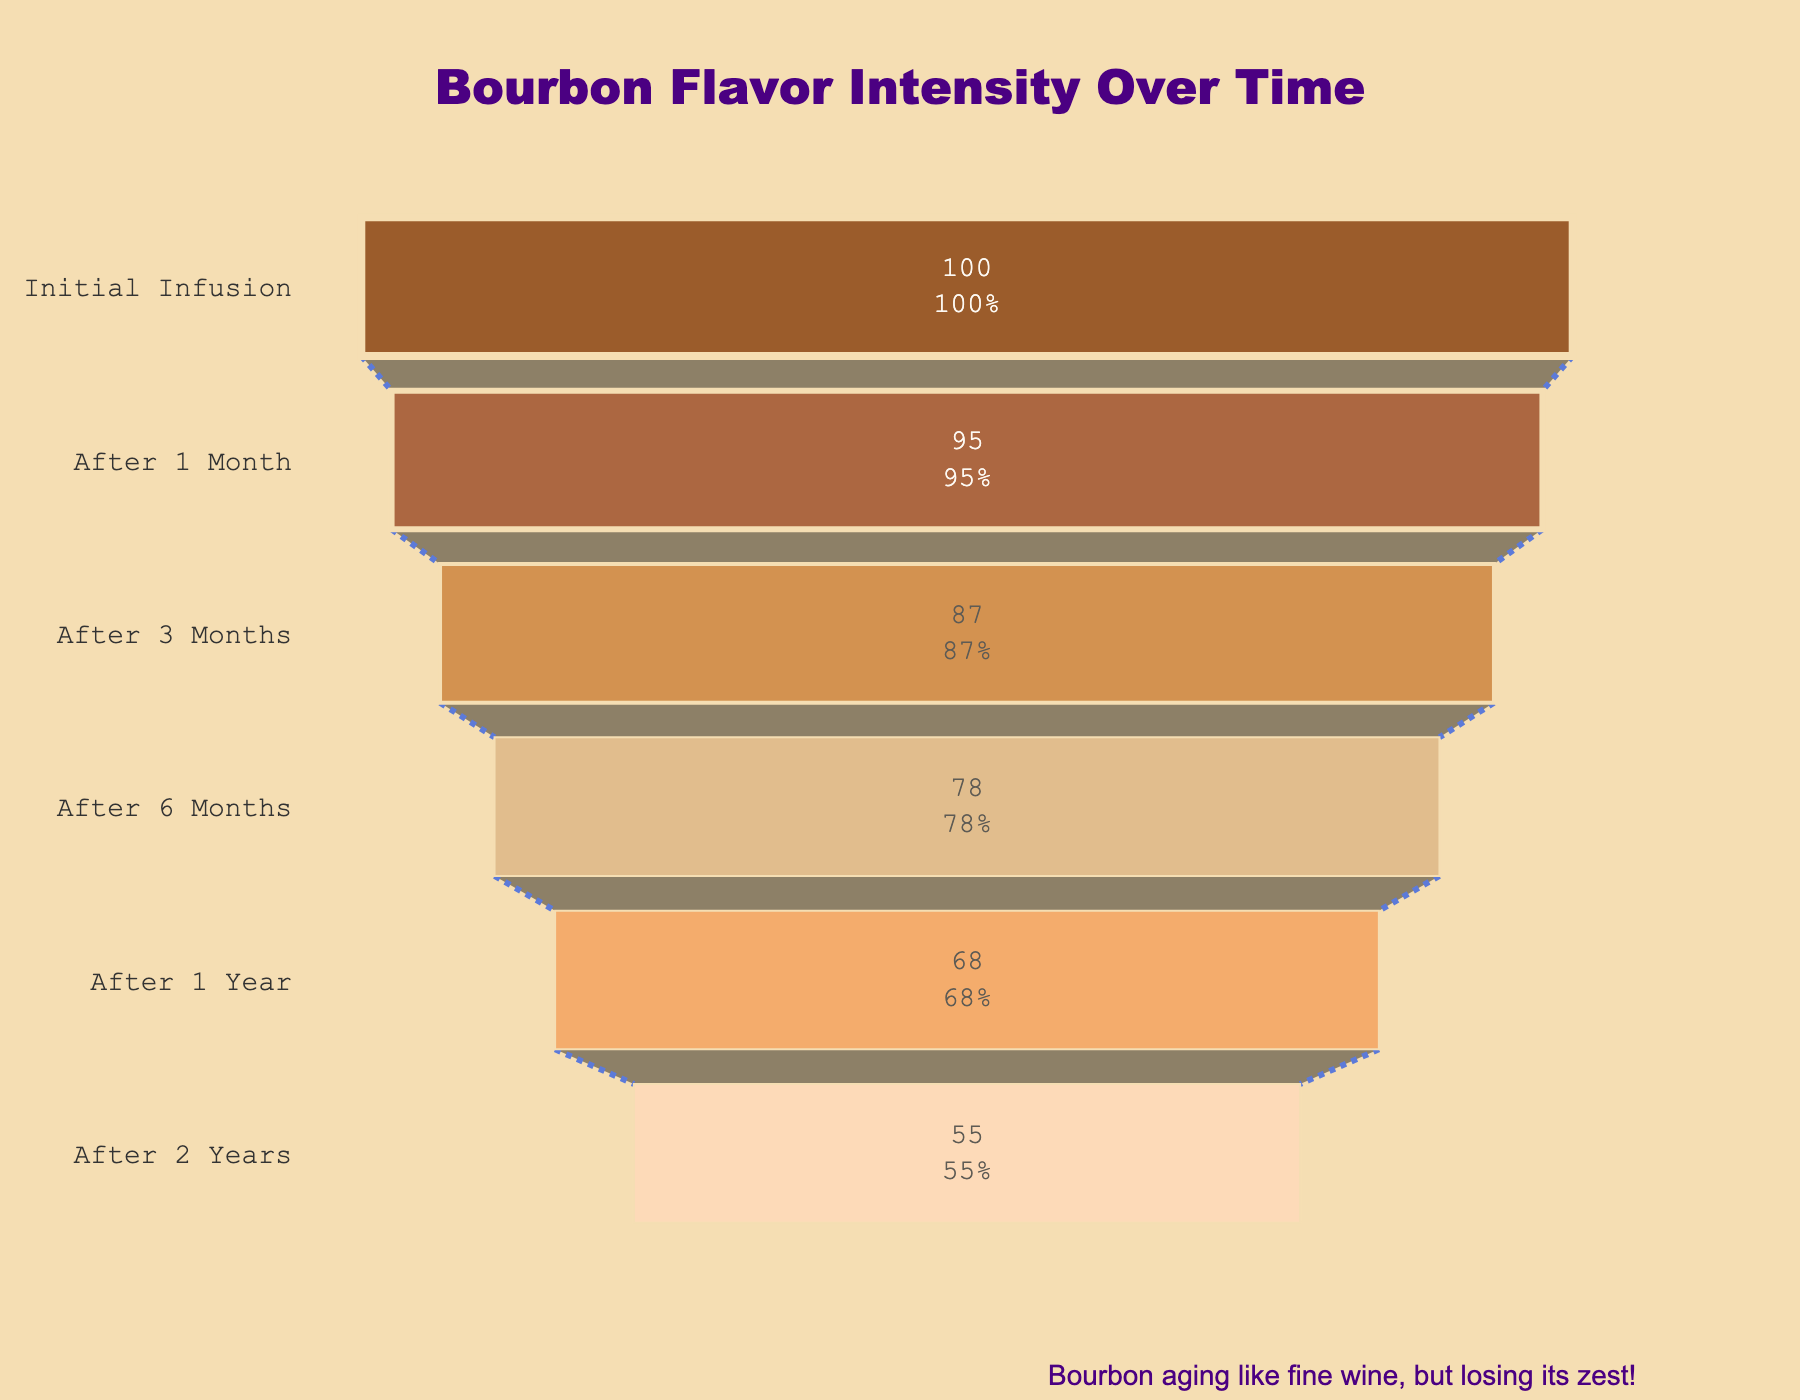What is the title of the chart? The title of the chart is prominently displayed at the top of the figure. It reads "Bourbon Flavor Intensity Over Time".
Answer: Bourbon Flavor Intensity Over Time How many stages of flavor intensity are shown? The funnel chart divides the bourbon flavor intensity into six distinct stages, ranging from "Initial Infusion" to "After 2 Years".
Answer: Six Which stage shows the highest remaining flavor intensity? In a funnel chart, the widest section at the top shows the highest remaining flavor intensity, which corresponds to the "Initial Infusion" stage at 100%.
Answer: Initial Infusion By how much does the percentage of flavor intensity reduce between the 1-month and the 3-month stages? The flavor intensity reduces from 95% at the 1-month stage to 87% at the 3-month stage. The difference is calculated as 95% - 87% = 8%.
Answer: 8% What percentage of flavor intensity remains after 1 year? By referencing the chart, the "After 1 Year" section indicates that 68% of the flavor intensity remains.
Answer: 68% How does the flavor intensity reduction between the first three months (Initial Infusion to After 3 Months) compare to the last three months in the chart (After 1 Year to After 2 Years)? The flavor intensity reduces from 100% to 87% in the first three months, which is a reduction of 13%. In the last three months, it reduces from 68% to 55%, which is a reduction of 13% as well. Both reductions are equal.
Answer: Equal What is the average percentage remaining of flavor intensity over all stages shown? To calculate the average percentage remaining, sum the percentages (100% + 95% + 87% + 78% + 68% + 55%) and divide by the number of stages (6). This sum is 483%, so the average is 483% / 6 = 80.5%.
Answer: 80.5% Which time period shows the steepest reduction in flavor intensity? By comparing the percentage reductions between consecutive stages, the period from "After 1 Year" (68%) to "After 2 Years" (55%) shows the largest drop of 13%.
Answer: After 1 Year to After 2 Years What color is used to represent the "After 6 Months" stage? The funnel chart uses a specific palette of colors for each stage. The "After 6 Months" stage is depicted in a tan-like color represented here by "DEB887".
Answer: Tan-like color 